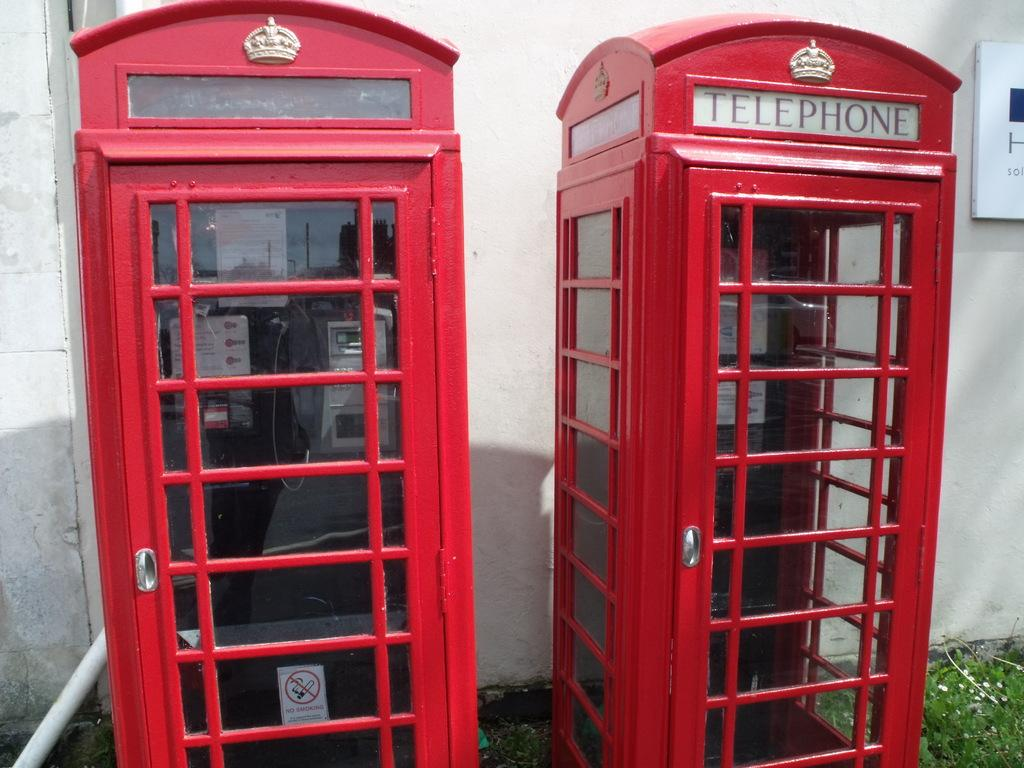Provide a one-sentence caption for the provided image. Two red telephone booths stand next to eachother, one with a no smoking sign. 